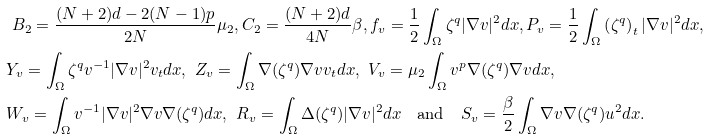<formula> <loc_0><loc_0><loc_500><loc_500>& \ B _ { 2 } = \frac { ( N + 2 ) d - 2 ( N - 1 ) p } { 2 N } \mu _ { 2 } , C _ { 2 } = \frac { ( N + 2 ) d } { 4 N } \beta , f _ { v } = \frac { 1 } { 2 } \int _ { \Omega } \zeta ^ { q } | \nabla v | ^ { 2 } d x , P _ { v } = \frac { 1 } { 2 } \int _ { \Omega } \left ( \zeta ^ { q } \right ) _ { t } | \nabla v | ^ { 2 } d x , \\ & Y _ { v } = \int _ { \Omega } \zeta ^ { q } v ^ { - 1 } | \nabla v | ^ { 2 } v _ { t } d x , \ Z _ { v } = \int _ { \Omega } \nabla ( \zeta ^ { q } ) \nabla v v _ { t } d x , \ V _ { v } = \mu _ { 2 } \int _ { \Omega } v ^ { p } \nabla ( \zeta ^ { q } ) \nabla v d x , \\ & W _ { v } = \int _ { \Omega } v ^ { - 1 } | \nabla v | ^ { 2 } \nabla v \nabla ( \zeta ^ { q } ) d x , \ R _ { v } = \int _ { \Omega } \Delta ( \zeta ^ { q } ) | \nabla v | ^ { 2 } d x \quad \text {and} \quad S _ { v } = \frac { \beta } { 2 } \int _ { \Omega } \nabla v \nabla ( \zeta ^ { q } ) u ^ { 2 } d x .</formula> 